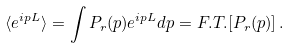Convert formula to latex. <formula><loc_0><loc_0><loc_500><loc_500>\langle e ^ { i p L } \rangle = \int P _ { r } ( p ) e ^ { i p L } d p = F . T . [ P _ { r } ( p ) ] \, . \,</formula> 